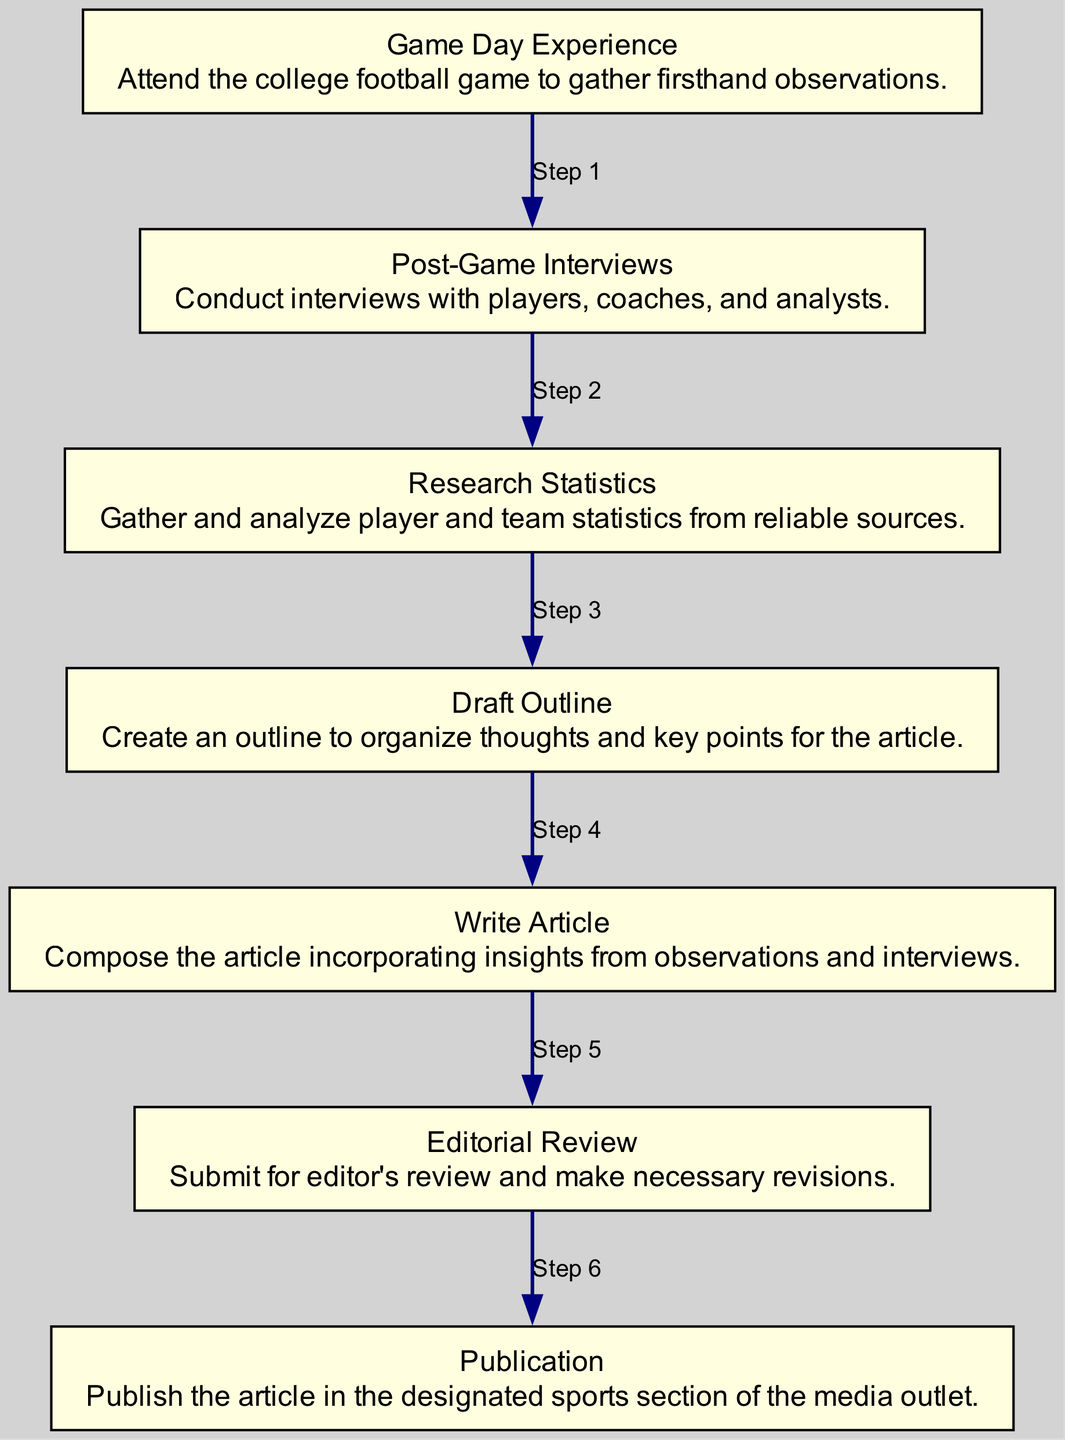What is the first step in the article writing process? The diagram indicates the first step as "Game Day Experience," which is where the writer attends the game to gather firsthand observations.
Answer: Game Day Experience How many steps are there in total? The diagram lists a total of seven distinct steps involved in the process, from the game day experience to publication.
Answer: Seven What is the last step before publication? According to the diagram, "Editorial Review" is the step directly preceding the final publication of the article.
Answer: Editorial Review What is the purpose of the "Draft Outline" step? The "Draft Outline" step is for creating an outline to organize thoughts and key points for the article, serving as a framework for the writing process.
Answer: Organize thoughts Which two steps come after "Post-Game Interviews"? Following "Post-Game Interviews," the next steps are "Research Statistics" and then "Draft Outline," indicating the sequence in which they occur.
Answer: Research Statistics and Draft Outline What action begins the article writing process? The process initiates with the action of attending the college football game, highlighted as the first step in the flow chart.
Answer: Attend the college football game What role does "Editorial Review" serve in the writing process? "Editorial Review" serves as the quality control step where the article is submitted for the editor's feedback and necessary revisions are made before publication.
Answer: Quality control Which step involves gathering player and team statistics? The step labeled "Research Statistics" clearly indicates that this segment is dedicated to gathering and analyzing player and team statistics for the article.
Answer: Research Statistics What is the central activity in the "Write Article" step? In the "Write Article" step, the central activity is to compose the article, utilizing insights gathered from both observations and interviews conducted earlier.
Answer: Compose the article 